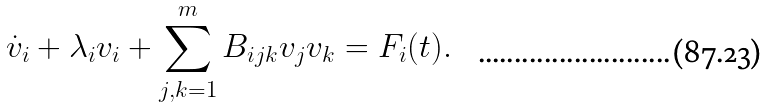Convert formula to latex. <formula><loc_0><loc_0><loc_500><loc_500>\dot { v } _ { i } + \lambda _ { i } v _ { i } + \sum _ { j , k = 1 } ^ { m } B _ { i j k } v _ { j } v _ { k } = F _ { i } ( t ) .</formula> 